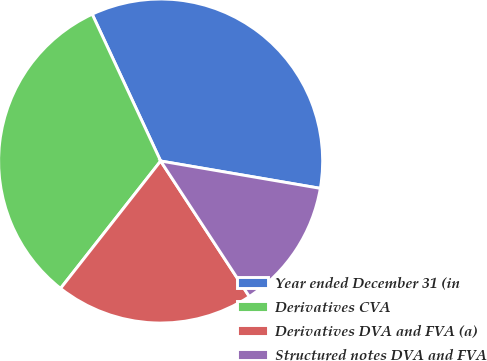Convert chart to OTSL. <chart><loc_0><loc_0><loc_500><loc_500><pie_chart><fcel>Year ended December 31 (in<fcel>Derivatives CVA<fcel>Derivatives DVA and FVA (a)<fcel>Structured notes DVA and FVA<nl><fcel>34.64%<fcel>32.46%<fcel>19.82%<fcel>13.08%<nl></chart> 